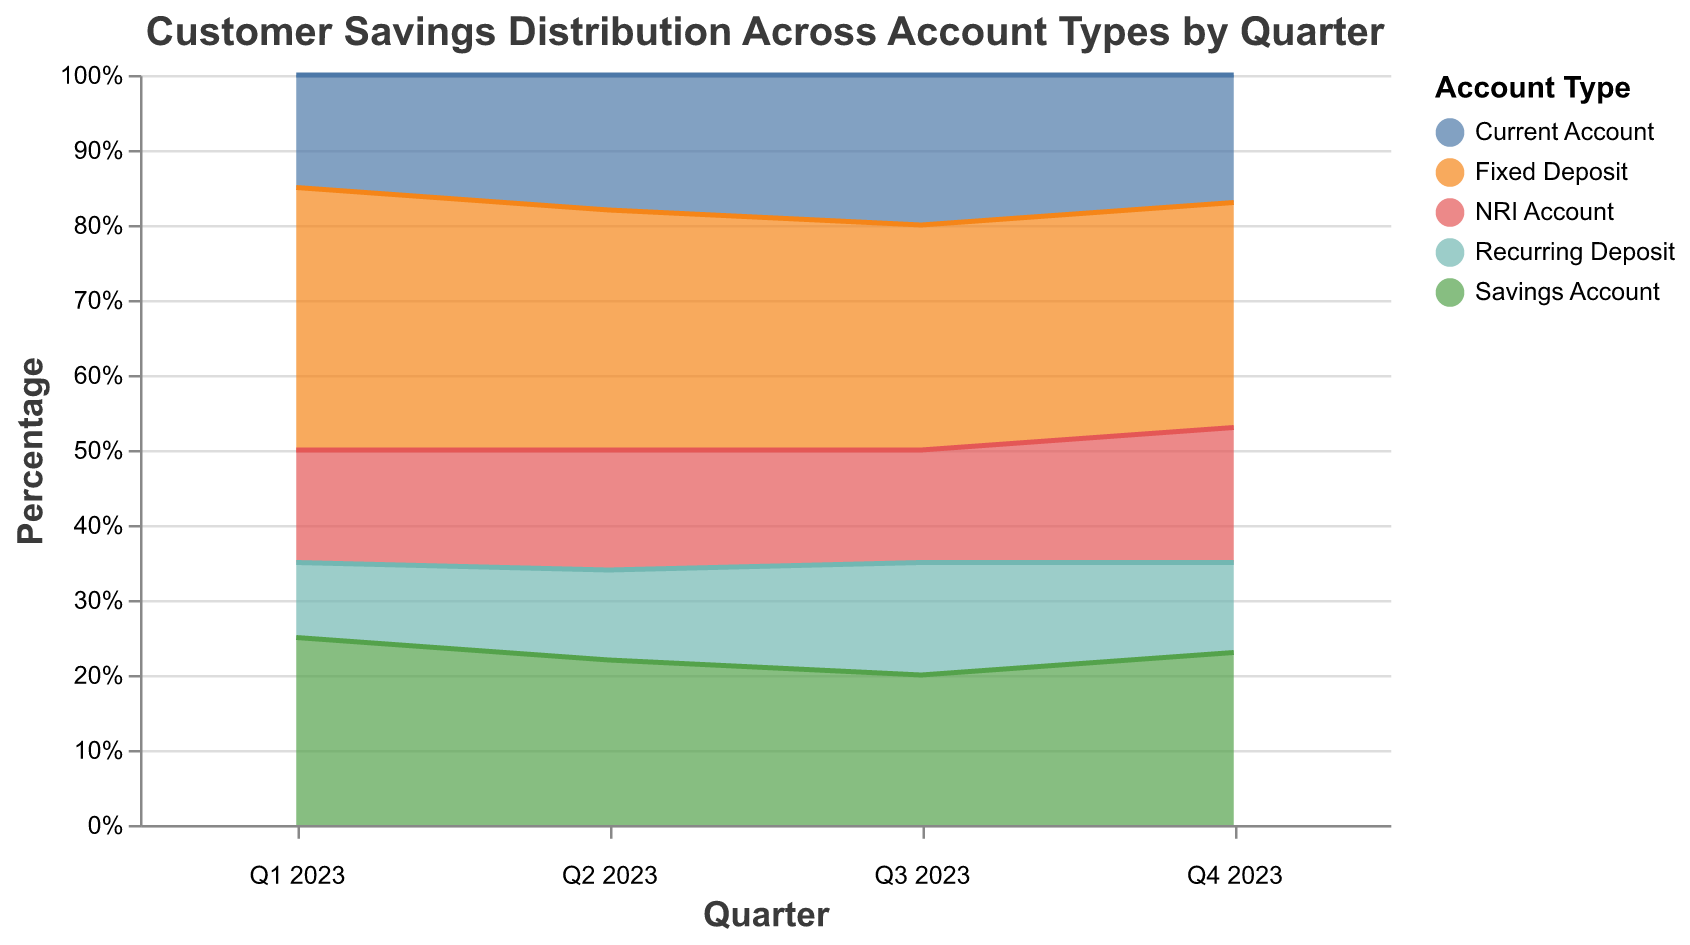What is the title of the chart? The title is displayed at the top center of the chart. It reads "Customer Savings Distribution Across Account Types by Quarter".
Answer: Customer Savings Distribution Across Account Types by Quarter Which account type had the highest percentage in Q1 2023? The highest percentage can be found by looking at the uppermost layer in the Q1 2023 segment. The "Fixed Deposit" account type is at the top of Q1 2023.
Answer: Fixed Deposit How did the percentage of Current Account change from Q1 2023 to Q4 2023? The percentage for Current Account in Q1 2023 is 15% and in Q4 2023 it is 17%. The change is calculated as 17% - 15% = 2%.
Answer: Increased by 2% Which quarter had the highest percentage for Fixed Deposit? By comparing the heights of the Fixed Deposit sections across all quarters, Q1 2023 and Q4 2023 both hold the highest percentage at 35% and 30% respectively.
Answer: Q1 2023 Which account type showed the most consistency in percentage across all quarters? Evaluating the stability of the lines for each account type across all quarters, the "NRI Account" maintained consistent percentages around 15-18%.
Answer: NRI Account Compare the total percentage of Savings Account between Q1 2023 and Q4 2023. The Savings Account percentage in Q1 2023 is 25% and in Q4 2023 it is 23%. The total difference is 25% - 23% = 2%.
Answer: Decreased by 2% What was the trend for Recurring Deposit from Q1 2023 to Q4 2023? Observing the percentage for Recurring Deposit over all quarters, it starts at 10% in Q1 2023 and increases to 15% in Q3 2023 before slightly dropping back to 12% in Q4 2023.
Answer: General increase with slight drop in Q4 2023 Which account type showed the most significant increase in percentage from Q1 2023 to Q4 2023? By examining the increase in percentage from Q1 to Q4 for each account type, "NRI Account" increased from 15% to 18%, which is the largest increase.
Answer: NRI Account What was the percentage of Savings Account in Q2 2023? By checking the percentage data for the Savings Account in Q2 2023, the value is 22%.
Answer: 22% Calculate the average percentage of Fixed Deposit across all quarters. The Fixed Deposit percentages for all quarters are Q1: 35%, Q2: 32%, Q3: 30%, and Q4: 30%. The average percentage is calculated as (35 + 32 + 30 + 30) / 4 = 31.75%.
Answer: 31.75% 